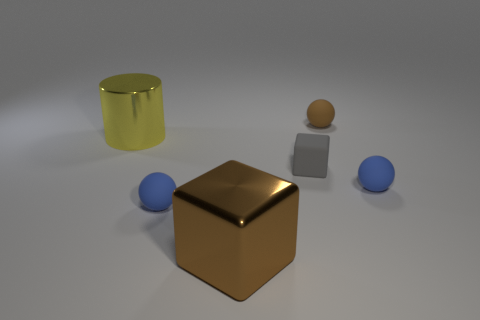There is a brown sphere that is the same size as the gray cube; what is its material?
Offer a very short reply. Rubber. What is the color of the tiny rubber thing that is the same shape as the large brown object?
Offer a very short reply. Gray. There is a small object that is right of the tiny brown thing; is its shape the same as the tiny brown thing?
Your answer should be compact. Yes. How many things are large green metal spheres or things to the right of the big yellow cylinder?
Keep it short and to the point. 5. Do the blue ball left of the gray cube and the big yellow object have the same material?
Keep it short and to the point. No. Is there anything else that has the same size as the cylinder?
Ensure brevity in your answer.  Yes. What material is the thing in front of the sphere that is left of the brown shiny thing made of?
Your answer should be very brief. Metal. Are there more big metal things in front of the tiny gray matte block than small spheres that are left of the large metal cube?
Offer a terse response. No. What is the size of the gray rubber cube?
Your answer should be very brief. Small. Is the color of the ball that is left of the brown ball the same as the large block?
Ensure brevity in your answer.  No. 